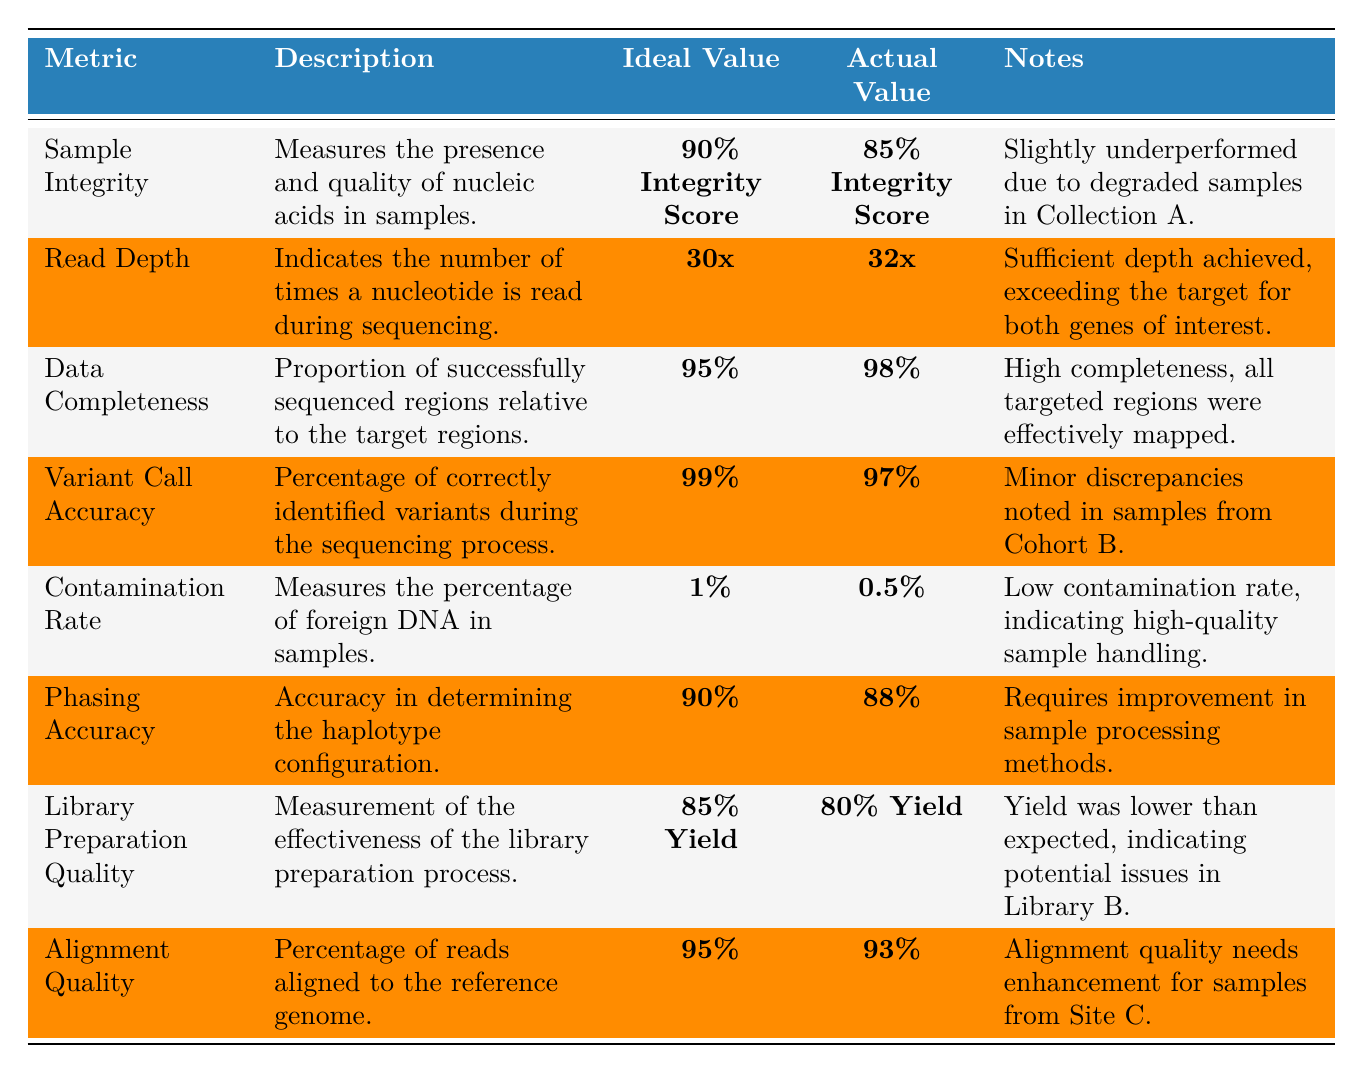What is the actual value for Sample Integrity? The actual value for Sample Integrity is found in the table under the Actual Value column corresponding to that metric. It shows 85% Integrity Score.
Answer: 85% Integrity Score Is the contamination rate below the ideal value? The ideal value for the contamination rate, under Ideal Value, is ≤ 1%. The actual value is 0.5%, which is below the ideal value.
Answer: Yes Which metric has the highest actual value? By comparing the Actual Values for all metrics, Data Completeness has the highest value at 98%.
Answer: Data Completeness What is the difference between the ideal value and the actual value for Library Preparation Quality? The ideal value for Library Preparation Quality is ≥ 85% Yield, while the actual value is 80% Yield. Subtracting the actual from the ideal gives a difference of 85% - 80% = 5%.
Answer: 5% Are all actual values meeting the ideal targets? To determine this, we will check each actual value against its corresponding ideal target. Sample Integrity (85% vs 90%), Variant Call Accuracy (97% vs 99%), Library Preparation Quality (80% vs 85%), and Alignment Quality (93% vs 95%) are below their ideal targets.
Answer: No What is the average actual value of all the metrics in the table? First, sum the actual values: 85 + 32 + 98 + 97 + 0.5 + 88 + 80 + 93 = 573. There are 8 metrics, so the average is 573/8 = 71.625.
Answer: 71.625 How many metrics are below their ideal values? By reviewing the table, the metrics below their ideal values are Sample Integrity, Variant Call Accuracy, Phasing Accuracy, Library Preparation Quality, and Alignment Quality, making a total of 5 metrics.
Answer: 5 What can be inferred about the Read Depth metric? The actual value of Read Depth is 32x, which exceeds the ideal value of ≥ 30x. This indicates that the sequencing depth was adequate for the study objectives.
Answer: Adequate depth achieved 